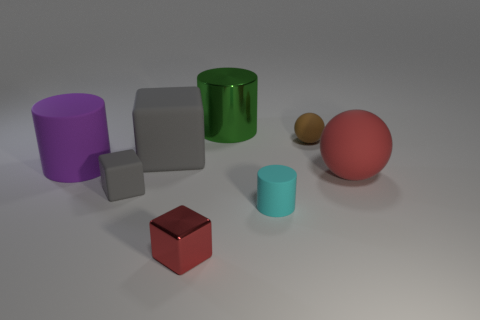There is a block that is the same color as the big matte ball; what material is it?
Ensure brevity in your answer.  Metal. There is a thing that is the same color as the large matte sphere; what is its shape?
Offer a terse response. Cube. There is a block that is the same size as the purple rubber cylinder; what is its color?
Your answer should be compact. Gray. Is there a small shiny cylinder that has the same color as the large cube?
Provide a short and direct response. No. There is a metal thing to the right of the red metal thing; is it the same size as the gray thing that is behind the large red object?
Your answer should be very brief. Yes. What is the material of the large object that is right of the small red metallic cube and behind the purple matte object?
Offer a very short reply. Metal. There is a metal block that is the same color as the large ball; what is its size?
Provide a succinct answer. Small. What is the material of the ball behind the purple rubber thing?
Keep it short and to the point. Rubber. Does the cyan rubber object have the same shape as the brown matte thing?
Make the answer very short. No. How many other things are there of the same shape as the large red thing?
Offer a very short reply. 1. 